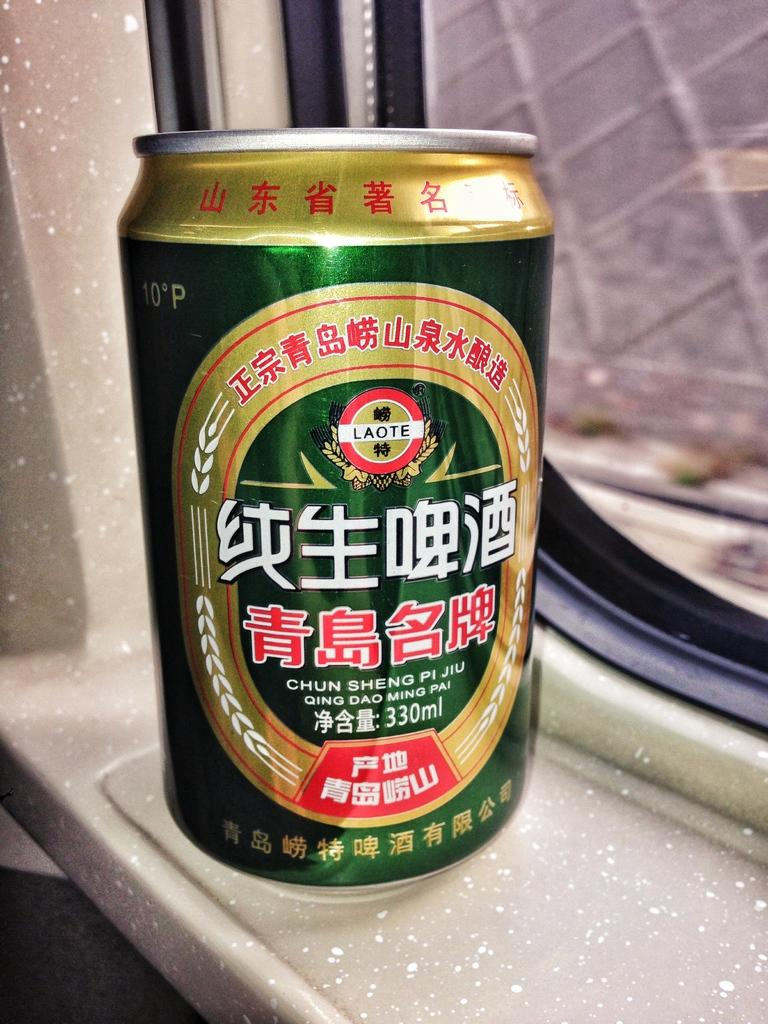Provide a one-sentence caption for the provided image. A green can says Chun Sheng Pi Jiu and is sitting in a window sill. 